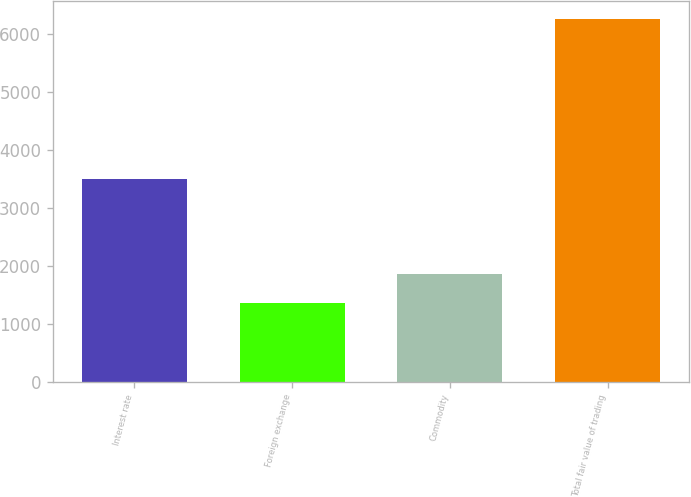Convert chart to OTSL. <chart><loc_0><loc_0><loc_500><loc_500><bar_chart><fcel>Interest rate<fcel>Foreign exchange<fcel>Commodity<fcel>Total fair value of trading<nl><fcel>3490<fcel>1359<fcel>1847.4<fcel>6243<nl></chart> 